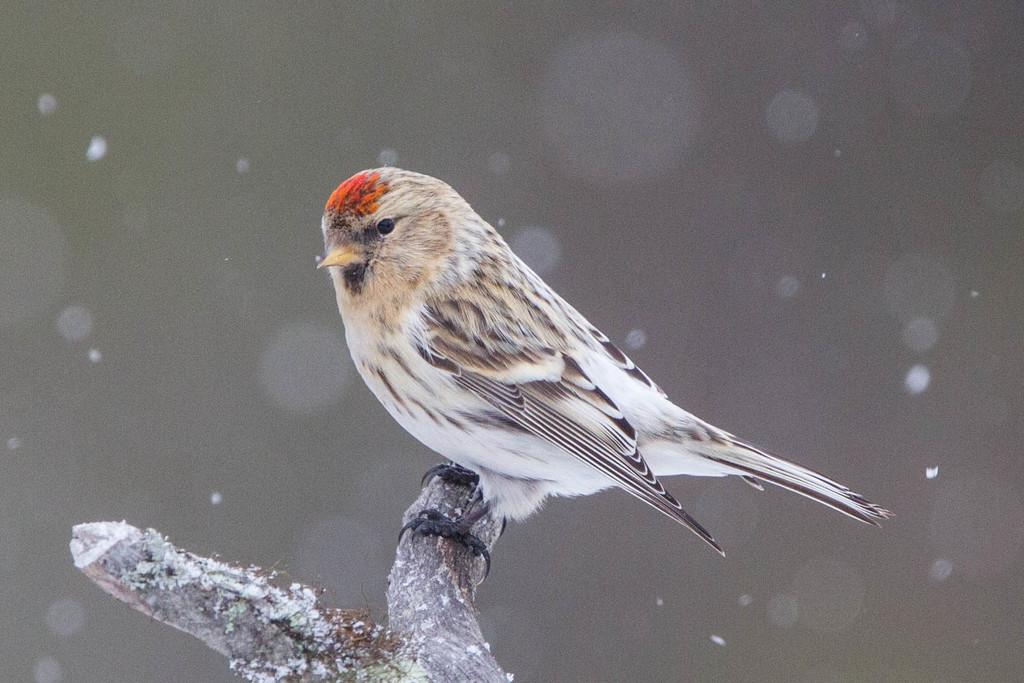What is the main subject in the center of the image? There is a word in the center of the image. What other object or animal is present in the image? There is a bird on wood in the image. What color scheme is used for the bird? The bird is in black and white color. How many cows can be seen in the image? There are no cows present in the image; it features a word and a bird on wood. What type of toad is sitting on the bird in the image? There is no toad present in the image; it only features a bird on wood. 